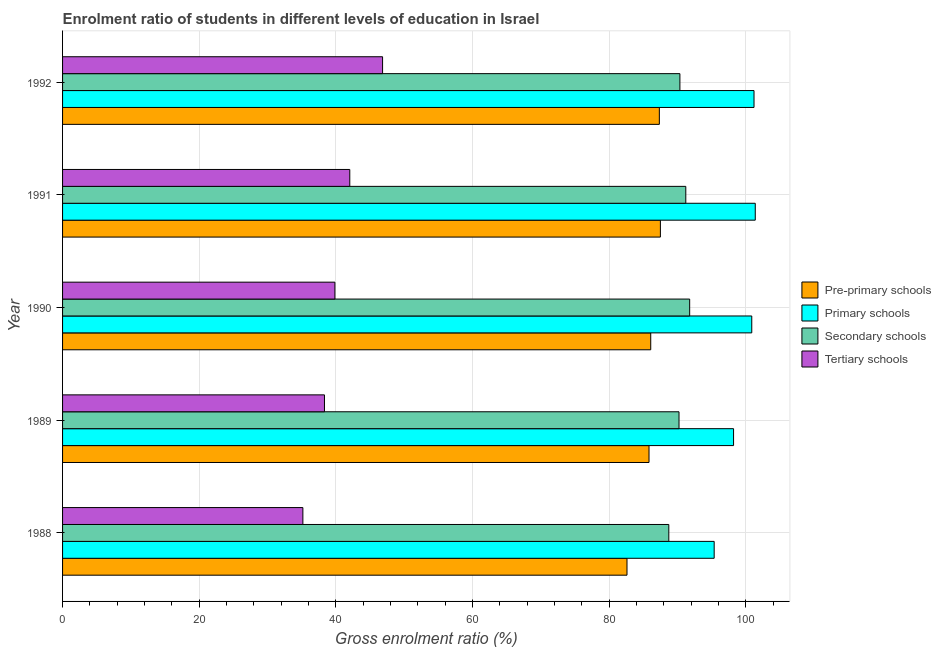How many different coloured bars are there?
Give a very brief answer. 4. How many groups of bars are there?
Your answer should be very brief. 5. Are the number of bars per tick equal to the number of legend labels?
Your answer should be compact. Yes. How many bars are there on the 4th tick from the top?
Offer a very short reply. 4. What is the label of the 2nd group of bars from the top?
Your answer should be very brief. 1991. What is the gross enrolment ratio in secondary schools in 1992?
Give a very brief answer. 90.36. Across all years, what is the maximum gross enrolment ratio in tertiary schools?
Ensure brevity in your answer.  46.84. Across all years, what is the minimum gross enrolment ratio in tertiary schools?
Offer a very short reply. 35.17. What is the total gross enrolment ratio in tertiary schools in the graph?
Provide a short and direct response. 202.24. What is the difference between the gross enrolment ratio in primary schools in 1988 and that in 1992?
Offer a terse response. -5.83. What is the difference between the gross enrolment ratio in primary schools in 1988 and the gross enrolment ratio in pre-primary schools in 1990?
Keep it short and to the point. 9.29. What is the average gross enrolment ratio in secondary schools per year?
Your answer should be very brief. 90.46. In the year 1990, what is the difference between the gross enrolment ratio in secondary schools and gross enrolment ratio in pre-primary schools?
Provide a succinct answer. 5.7. In how many years, is the gross enrolment ratio in secondary schools greater than 16 %?
Ensure brevity in your answer.  5. What is the ratio of the gross enrolment ratio in secondary schools in 1988 to that in 1991?
Keep it short and to the point. 0.97. What is the difference between the highest and the second highest gross enrolment ratio in tertiary schools?
Your answer should be very brief. 4.8. What is the difference between the highest and the lowest gross enrolment ratio in primary schools?
Offer a terse response. 6.01. In how many years, is the gross enrolment ratio in primary schools greater than the average gross enrolment ratio in primary schools taken over all years?
Give a very brief answer. 3. Is the sum of the gross enrolment ratio in secondary schools in 1988 and 1992 greater than the maximum gross enrolment ratio in primary schools across all years?
Ensure brevity in your answer.  Yes. Is it the case that in every year, the sum of the gross enrolment ratio in primary schools and gross enrolment ratio in pre-primary schools is greater than the sum of gross enrolment ratio in secondary schools and gross enrolment ratio in tertiary schools?
Make the answer very short. Yes. What does the 3rd bar from the top in 1990 represents?
Provide a short and direct response. Primary schools. What does the 3rd bar from the bottom in 1989 represents?
Provide a succinct answer. Secondary schools. Is it the case that in every year, the sum of the gross enrolment ratio in pre-primary schools and gross enrolment ratio in primary schools is greater than the gross enrolment ratio in secondary schools?
Your answer should be very brief. Yes. How many bars are there?
Offer a very short reply. 20. Are all the bars in the graph horizontal?
Ensure brevity in your answer.  Yes. Are the values on the major ticks of X-axis written in scientific E-notation?
Keep it short and to the point. No. Does the graph contain any zero values?
Give a very brief answer. No. Where does the legend appear in the graph?
Give a very brief answer. Center right. What is the title of the graph?
Offer a terse response. Enrolment ratio of students in different levels of education in Israel. Does "Other expenses" appear as one of the legend labels in the graph?
Offer a terse response. No. What is the label or title of the X-axis?
Ensure brevity in your answer.  Gross enrolment ratio (%). What is the label or title of the Y-axis?
Your response must be concise. Year. What is the Gross enrolment ratio (%) of Pre-primary schools in 1988?
Make the answer very short. 82.61. What is the Gross enrolment ratio (%) in Primary schools in 1988?
Offer a terse response. 95.37. What is the Gross enrolment ratio (%) in Secondary schools in 1988?
Make the answer very short. 88.73. What is the Gross enrolment ratio (%) in Tertiary schools in 1988?
Keep it short and to the point. 35.17. What is the Gross enrolment ratio (%) of Pre-primary schools in 1989?
Make the answer very short. 85.83. What is the Gross enrolment ratio (%) in Primary schools in 1989?
Offer a very short reply. 98.21. What is the Gross enrolment ratio (%) of Secondary schools in 1989?
Provide a succinct answer. 90.22. What is the Gross enrolment ratio (%) in Tertiary schools in 1989?
Offer a terse response. 38.33. What is the Gross enrolment ratio (%) of Pre-primary schools in 1990?
Your response must be concise. 86.08. What is the Gross enrolment ratio (%) of Primary schools in 1990?
Your answer should be very brief. 100.87. What is the Gross enrolment ratio (%) of Secondary schools in 1990?
Your answer should be very brief. 91.79. What is the Gross enrolment ratio (%) in Tertiary schools in 1990?
Give a very brief answer. 39.86. What is the Gross enrolment ratio (%) of Pre-primary schools in 1991?
Provide a succinct answer. 87.5. What is the Gross enrolment ratio (%) of Primary schools in 1991?
Offer a terse response. 101.38. What is the Gross enrolment ratio (%) in Secondary schools in 1991?
Offer a very short reply. 91.22. What is the Gross enrolment ratio (%) in Tertiary schools in 1991?
Make the answer very short. 42.04. What is the Gross enrolment ratio (%) in Pre-primary schools in 1992?
Your answer should be very brief. 87.35. What is the Gross enrolment ratio (%) of Primary schools in 1992?
Ensure brevity in your answer.  101.2. What is the Gross enrolment ratio (%) of Secondary schools in 1992?
Provide a short and direct response. 90.36. What is the Gross enrolment ratio (%) in Tertiary schools in 1992?
Ensure brevity in your answer.  46.84. Across all years, what is the maximum Gross enrolment ratio (%) in Pre-primary schools?
Provide a succinct answer. 87.5. Across all years, what is the maximum Gross enrolment ratio (%) of Primary schools?
Keep it short and to the point. 101.38. Across all years, what is the maximum Gross enrolment ratio (%) of Secondary schools?
Your response must be concise. 91.79. Across all years, what is the maximum Gross enrolment ratio (%) in Tertiary schools?
Offer a terse response. 46.84. Across all years, what is the minimum Gross enrolment ratio (%) of Pre-primary schools?
Make the answer very short. 82.61. Across all years, what is the minimum Gross enrolment ratio (%) of Primary schools?
Give a very brief answer. 95.37. Across all years, what is the minimum Gross enrolment ratio (%) in Secondary schools?
Your response must be concise. 88.73. Across all years, what is the minimum Gross enrolment ratio (%) of Tertiary schools?
Provide a succinct answer. 35.17. What is the total Gross enrolment ratio (%) of Pre-primary schools in the graph?
Provide a short and direct response. 429.37. What is the total Gross enrolment ratio (%) in Primary schools in the graph?
Ensure brevity in your answer.  497.04. What is the total Gross enrolment ratio (%) of Secondary schools in the graph?
Provide a succinct answer. 452.31. What is the total Gross enrolment ratio (%) in Tertiary schools in the graph?
Your answer should be very brief. 202.24. What is the difference between the Gross enrolment ratio (%) of Pre-primary schools in 1988 and that in 1989?
Make the answer very short. -3.22. What is the difference between the Gross enrolment ratio (%) in Primary schools in 1988 and that in 1989?
Keep it short and to the point. -2.84. What is the difference between the Gross enrolment ratio (%) of Secondary schools in 1988 and that in 1989?
Keep it short and to the point. -1.49. What is the difference between the Gross enrolment ratio (%) of Tertiary schools in 1988 and that in 1989?
Keep it short and to the point. -3.16. What is the difference between the Gross enrolment ratio (%) in Pre-primary schools in 1988 and that in 1990?
Ensure brevity in your answer.  -3.47. What is the difference between the Gross enrolment ratio (%) in Primary schools in 1988 and that in 1990?
Make the answer very short. -5.5. What is the difference between the Gross enrolment ratio (%) of Secondary schools in 1988 and that in 1990?
Your response must be concise. -3.05. What is the difference between the Gross enrolment ratio (%) in Tertiary schools in 1988 and that in 1990?
Provide a succinct answer. -4.69. What is the difference between the Gross enrolment ratio (%) in Pre-primary schools in 1988 and that in 1991?
Offer a very short reply. -4.89. What is the difference between the Gross enrolment ratio (%) in Primary schools in 1988 and that in 1991?
Offer a terse response. -6.01. What is the difference between the Gross enrolment ratio (%) in Secondary schools in 1988 and that in 1991?
Keep it short and to the point. -2.49. What is the difference between the Gross enrolment ratio (%) of Tertiary schools in 1988 and that in 1991?
Ensure brevity in your answer.  -6.87. What is the difference between the Gross enrolment ratio (%) of Pre-primary schools in 1988 and that in 1992?
Your response must be concise. -4.74. What is the difference between the Gross enrolment ratio (%) of Primary schools in 1988 and that in 1992?
Give a very brief answer. -5.83. What is the difference between the Gross enrolment ratio (%) in Secondary schools in 1988 and that in 1992?
Make the answer very short. -1.62. What is the difference between the Gross enrolment ratio (%) in Tertiary schools in 1988 and that in 1992?
Provide a succinct answer. -11.67. What is the difference between the Gross enrolment ratio (%) in Primary schools in 1989 and that in 1990?
Make the answer very short. -2.67. What is the difference between the Gross enrolment ratio (%) in Secondary schools in 1989 and that in 1990?
Your response must be concise. -1.56. What is the difference between the Gross enrolment ratio (%) in Tertiary schools in 1989 and that in 1990?
Give a very brief answer. -1.53. What is the difference between the Gross enrolment ratio (%) in Pre-primary schools in 1989 and that in 1991?
Make the answer very short. -1.66. What is the difference between the Gross enrolment ratio (%) in Primary schools in 1989 and that in 1991?
Give a very brief answer. -3.18. What is the difference between the Gross enrolment ratio (%) in Secondary schools in 1989 and that in 1991?
Your response must be concise. -0.99. What is the difference between the Gross enrolment ratio (%) in Tertiary schools in 1989 and that in 1991?
Your answer should be compact. -3.71. What is the difference between the Gross enrolment ratio (%) of Pre-primary schools in 1989 and that in 1992?
Offer a very short reply. -1.51. What is the difference between the Gross enrolment ratio (%) in Primary schools in 1989 and that in 1992?
Your answer should be compact. -3. What is the difference between the Gross enrolment ratio (%) in Secondary schools in 1989 and that in 1992?
Make the answer very short. -0.13. What is the difference between the Gross enrolment ratio (%) in Tertiary schools in 1989 and that in 1992?
Keep it short and to the point. -8.5. What is the difference between the Gross enrolment ratio (%) of Pre-primary schools in 1990 and that in 1991?
Ensure brevity in your answer.  -1.41. What is the difference between the Gross enrolment ratio (%) of Primary schools in 1990 and that in 1991?
Ensure brevity in your answer.  -0.51. What is the difference between the Gross enrolment ratio (%) in Secondary schools in 1990 and that in 1991?
Keep it short and to the point. 0.57. What is the difference between the Gross enrolment ratio (%) of Tertiary schools in 1990 and that in 1991?
Your answer should be very brief. -2.18. What is the difference between the Gross enrolment ratio (%) of Pre-primary schools in 1990 and that in 1992?
Ensure brevity in your answer.  -1.26. What is the difference between the Gross enrolment ratio (%) of Primary schools in 1990 and that in 1992?
Provide a short and direct response. -0.33. What is the difference between the Gross enrolment ratio (%) of Secondary schools in 1990 and that in 1992?
Make the answer very short. 1.43. What is the difference between the Gross enrolment ratio (%) of Tertiary schools in 1990 and that in 1992?
Make the answer very short. -6.98. What is the difference between the Gross enrolment ratio (%) in Pre-primary schools in 1991 and that in 1992?
Make the answer very short. 0.15. What is the difference between the Gross enrolment ratio (%) in Primary schools in 1991 and that in 1992?
Give a very brief answer. 0.18. What is the difference between the Gross enrolment ratio (%) of Secondary schools in 1991 and that in 1992?
Make the answer very short. 0.86. What is the difference between the Gross enrolment ratio (%) in Tertiary schools in 1991 and that in 1992?
Give a very brief answer. -4.8. What is the difference between the Gross enrolment ratio (%) in Pre-primary schools in 1988 and the Gross enrolment ratio (%) in Primary schools in 1989?
Offer a terse response. -15.6. What is the difference between the Gross enrolment ratio (%) of Pre-primary schools in 1988 and the Gross enrolment ratio (%) of Secondary schools in 1989?
Provide a succinct answer. -7.61. What is the difference between the Gross enrolment ratio (%) in Pre-primary schools in 1988 and the Gross enrolment ratio (%) in Tertiary schools in 1989?
Offer a terse response. 44.28. What is the difference between the Gross enrolment ratio (%) of Primary schools in 1988 and the Gross enrolment ratio (%) of Secondary schools in 1989?
Give a very brief answer. 5.15. What is the difference between the Gross enrolment ratio (%) of Primary schools in 1988 and the Gross enrolment ratio (%) of Tertiary schools in 1989?
Give a very brief answer. 57.04. What is the difference between the Gross enrolment ratio (%) in Secondary schools in 1988 and the Gross enrolment ratio (%) in Tertiary schools in 1989?
Make the answer very short. 50.4. What is the difference between the Gross enrolment ratio (%) in Pre-primary schools in 1988 and the Gross enrolment ratio (%) in Primary schools in 1990?
Your response must be concise. -18.26. What is the difference between the Gross enrolment ratio (%) in Pre-primary schools in 1988 and the Gross enrolment ratio (%) in Secondary schools in 1990?
Make the answer very short. -9.17. What is the difference between the Gross enrolment ratio (%) of Pre-primary schools in 1988 and the Gross enrolment ratio (%) of Tertiary schools in 1990?
Provide a succinct answer. 42.75. What is the difference between the Gross enrolment ratio (%) of Primary schools in 1988 and the Gross enrolment ratio (%) of Secondary schools in 1990?
Your answer should be compact. 3.58. What is the difference between the Gross enrolment ratio (%) of Primary schools in 1988 and the Gross enrolment ratio (%) of Tertiary schools in 1990?
Provide a short and direct response. 55.51. What is the difference between the Gross enrolment ratio (%) of Secondary schools in 1988 and the Gross enrolment ratio (%) of Tertiary schools in 1990?
Provide a succinct answer. 48.87. What is the difference between the Gross enrolment ratio (%) of Pre-primary schools in 1988 and the Gross enrolment ratio (%) of Primary schools in 1991?
Ensure brevity in your answer.  -18.77. What is the difference between the Gross enrolment ratio (%) in Pre-primary schools in 1988 and the Gross enrolment ratio (%) in Secondary schools in 1991?
Keep it short and to the point. -8.61. What is the difference between the Gross enrolment ratio (%) of Pre-primary schools in 1988 and the Gross enrolment ratio (%) of Tertiary schools in 1991?
Provide a short and direct response. 40.57. What is the difference between the Gross enrolment ratio (%) in Primary schools in 1988 and the Gross enrolment ratio (%) in Secondary schools in 1991?
Provide a short and direct response. 4.15. What is the difference between the Gross enrolment ratio (%) of Primary schools in 1988 and the Gross enrolment ratio (%) of Tertiary schools in 1991?
Make the answer very short. 53.33. What is the difference between the Gross enrolment ratio (%) in Secondary schools in 1988 and the Gross enrolment ratio (%) in Tertiary schools in 1991?
Make the answer very short. 46.69. What is the difference between the Gross enrolment ratio (%) in Pre-primary schools in 1988 and the Gross enrolment ratio (%) in Primary schools in 1992?
Ensure brevity in your answer.  -18.59. What is the difference between the Gross enrolment ratio (%) in Pre-primary schools in 1988 and the Gross enrolment ratio (%) in Secondary schools in 1992?
Provide a succinct answer. -7.74. What is the difference between the Gross enrolment ratio (%) in Pre-primary schools in 1988 and the Gross enrolment ratio (%) in Tertiary schools in 1992?
Make the answer very short. 35.77. What is the difference between the Gross enrolment ratio (%) in Primary schools in 1988 and the Gross enrolment ratio (%) in Secondary schools in 1992?
Offer a terse response. 5.01. What is the difference between the Gross enrolment ratio (%) of Primary schools in 1988 and the Gross enrolment ratio (%) of Tertiary schools in 1992?
Keep it short and to the point. 48.53. What is the difference between the Gross enrolment ratio (%) in Secondary schools in 1988 and the Gross enrolment ratio (%) in Tertiary schools in 1992?
Provide a succinct answer. 41.89. What is the difference between the Gross enrolment ratio (%) of Pre-primary schools in 1989 and the Gross enrolment ratio (%) of Primary schools in 1990?
Provide a succinct answer. -15.04. What is the difference between the Gross enrolment ratio (%) of Pre-primary schools in 1989 and the Gross enrolment ratio (%) of Secondary schools in 1990?
Provide a succinct answer. -5.95. What is the difference between the Gross enrolment ratio (%) of Pre-primary schools in 1989 and the Gross enrolment ratio (%) of Tertiary schools in 1990?
Your answer should be compact. 45.98. What is the difference between the Gross enrolment ratio (%) of Primary schools in 1989 and the Gross enrolment ratio (%) of Secondary schools in 1990?
Make the answer very short. 6.42. What is the difference between the Gross enrolment ratio (%) of Primary schools in 1989 and the Gross enrolment ratio (%) of Tertiary schools in 1990?
Keep it short and to the point. 58.35. What is the difference between the Gross enrolment ratio (%) in Secondary schools in 1989 and the Gross enrolment ratio (%) in Tertiary schools in 1990?
Offer a very short reply. 50.37. What is the difference between the Gross enrolment ratio (%) of Pre-primary schools in 1989 and the Gross enrolment ratio (%) of Primary schools in 1991?
Ensure brevity in your answer.  -15.55. What is the difference between the Gross enrolment ratio (%) of Pre-primary schools in 1989 and the Gross enrolment ratio (%) of Secondary schools in 1991?
Offer a very short reply. -5.38. What is the difference between the Gross enrolment ratio (%) of Pre-primary schools in 1989 and the Gross enrolment ratio (%) of Tertiary schools in 1991?
Keep it short and to the point. 43.8. What is the difference between the Gross enrolment ratio (%) in Primary schools in 1989 and the Gross enrolment ratio (%) in Secondary schools in 1991?
Your answer should be very brief. 6.99. What is the difference between the Gross enrolment ratio (%) in Primary schools in 1989 and the Gross enrolment ratio (%) in Tertiary schools in 1991?
Offer a terse response. 56.17. What is the difference between the Gross enrolment ratio (%) of Secondary schools in 1989 and the Gross enrolment ratio (%) of Tertiary schools in 1991?
Make the answer very short. 48.19. What is the difference between the Gross enrolment ratio (%) in Pre-primary schools in 1989 and the Gross enrolment ratio (%) in Primary schools in 1992?
Your answer should be compact. -15.37. What is the difference between the Gross enrolment ratio (%) of Pre-primary schools in 1989 and the Gross enrolment ratio (%) of Secondary schools in 1992?
Offer a terse response. -4.52. What is the difference between the Gross enrolment ratio (%) in Pre-primary schools in 1989 and the Gross enrolment ratio (%) in Tertiary schools in 1992?
Keep it short and to the point. 39. What is the difference between the Gross enrolment ratio (%) of Primary schools in 1989 and the Gross enrolment ratio (%) of Secondary schools in 1992?
Provide a succinct answer. 7.85. What is the difference between the Gross enrolment ratio (%) in Primary schools in 1989 and the Gross enrolment ratio (%) in Tertiary schools in 1992?
Ensure brevity in your answer.  51.37. What is the difference between the Gross enrolment ratio (%) of Secondary schools in 1989 and the Gross enrolment ratio (%) of Tertiary schools in 1992?
Provide a succinct answer. 43.39. What is the difference between the Gross enrolment ratio (%) of Pre-primary schools in 1990 and the Gross enrolment ratio (%) of Primary schools in 1991?
Your response must be concise. -15.3. What is the difference between the Gross enrolment ratio (%) in Pre-primary schools in 1990 and the Gross enrolment ratio (%) in Secondary schools in 1991?
Provide a succinct answer. -5.13. What is the difference between the Gross enrolment ratio (%) of Pre-primary schools in 1990 and the Gross enrolment ratio (%) of Tertiary schools in 1991?
Your answer should be compact. 44.05. What is the difference between the Gross enrolment ratio (%) of Primary schools in 1990 and the Gross enrolment ratio (%) of Secondary schools in 1991?
Offer a very short reply. 9.65. What is the difference between the Gross enrolment ratio (%) in Primary schools in 1990 and the Gross enrolment ratio (%) in Tertiary schools in 1991?
Keep it short and to the point. 58.83. What is the difference between the Gross enrolment ratio (%) of Secondary schools in 1990 and the Gross enrolment ratio (%) of Tertiary schools in 1991?
Your answer should be very brief. 49.75. What is the difference between the Gross enrolment ratio (%) in Pre-primary schools in 1990 and the Gross enrolment ratio (%) in Primary schools in 1992?
Your response must be concise. -15.12. What is the difference between the Gross enrolment ratio (%) of Pre-primary schools in 1990 and the Gross enrolment ratio (%) of Secondary schools in 1992?
Your answer should be very brief. -4.27. What is the difference between the Gross enrolment ratio (%) in Pre-primary schools in 1990 and the Gross enrolment ratio (%) in Tertiary schools in 1992?
Your response must be concise. 39.25. What is the difference between the Gross enrolment ratio (%) in Primary schools in 1990 and the Gross enrolment ratio (%) in Secondary schools in 1992?
Provide a short and direct response. 10.52. What is the difference between the Gross enrolment ratio (%) of Primary schools in 1990 and the Gross enrolment ratio (%) of Tertiary schools in 1992?
Your response must be concise. 54.03. What is the difference between the Gross enrolment ratio (%) of Secondary schools in 1990 and the Gross enrolment ratio (%) of Tertiary schools in 1992?
Your answer should be compact. 44.95. What is the difference between the Gross enrolment ratio (%) in Pre-primary schools in 1991 and the Gross enrolment ratio (%) in Primary schools in 1992?
Your answer should be very brief. -13.7. What is the difference between the Gross enrolment ratio (%) in Pre-primary schools in 1991 and the Gross enrolment ratio (%) in Secondary schools in 1992?
Keep it short and to the point. -2.86. What is the difference between the Gross enrolment ratio (%) of Pre-primary schools in 1991 and the Gross enrolment ratio (%) of Tertiary schools in 1992?
Ensure brevity in your answer.  40.66. What is the difference between the Gross enrolment ratio (%) of Primary schools in 1991 and the Gross enrolment ratio (%) of Secondary schools in 1992?
Provide a short and direct response. 11.03. What is the difference between the Gross enrolment ratio (%) in Primary schools in 1991 and the Gross enrolment ratio (%) in Tertiary schools in 1992?
Your response must be concise. 54.55. What is the difference between the Gross enrolment ratio (%) in Secondary schools in 1991 and the Gross enrolment ratio (%) in Tertiary schools in 1992?
Ensure brevity in your answer.  44.38. What is the average Gross enrolment ratio (%) of Pre-primary schools per year?
Your response must be concise. 85.87. What is the average Gross enrolment ratio (%) in Primary schools per year?
Your response must be concise. 99.41. What is the average Gross enrolment ratio (%) of Secondary schools per year?
Offer a very short reply. 90.46. What is the average Gross enrolment ratio (%) in Tertiary schools per year?
Your answer should be compact. 40.45. In the year 1988, what is the difference between the Gross enrolment ratio (%) in Pre-primary schools and Gross enrolment ratio (%) in Primary schools?
Your answer should be compact. -12.76. In the year 1988, what is the difference between the Gross enrolment ratio (%) of Pre-primary schools and Gross enrolment ratio (%) of Secondary schools?
Give a very brief answer. -6.12. In the year 1988, what is the difference between the Gross enrolment ratio (%) in Pre-primary schools and Gross enrolment ratio (%) in Tertiary schools?
Your answer should be very brief. 47.44. In the year 1988, what is the difference between the Gross enrolment ratio (%) of Primary schools and Gross enrolment ratio (%) of Secondary schools?
Ensure brevity in your answer.  6.64. In the year 1988, what is the difference between the Gross enrolment ratio (%) in Primary schools and Gross enrolment ratio (%) in Tertiary schools?
Make the answer very short. 60.2. In the year 1988, what is the difference between the Gross enrolment ratio (%) in Secondary schools and Gross enrolment ratio (%) in Tertiary schools?
Make the answer very short. 53.56. In the year 1989, what is the difference between the Gross enrolment ratio (%) of Pre-primary schools and Gross enrolment ratio (%) of Primary schools?
Keep it short and to the point. -12.37. In the year 1989, what is the difference between the Gross enrolment ratio (%) in Pre-primary schools and Gross enrolment ratio (%) in Secondary schools?
Your answer should be very brief. -4.39. In the year 1989, what is the difference between the Gross enrolment ratio (%) of Pre-primary schools and Gross enrolment ratio (%) of Tertiary schools?
Offer a very short reply. 47.5. In the year 1989, what is the difference between the Gross enrolment ratio (%) of Primary schools and Gross enrolment ratio (%) of Secondary schools?
Provide a succinct answer. 7.98. In the year 1989, what is the difference between the Gross enrolment ratio (%) of Primary schools and Gross enrolment ratio (%) of Tertiary schools?
Offer a very short reply. 59.87. In the year 1989, what is the difference between the Gross enrolment ratio (%) in Secondary schools and Gross enrolment ratio (%) in Tertiary schools?
Keep it short and to the point. 51.89. In the year 1990, what is the difference between the Gross enrolment ratio (%) of Pre-primary schools and Gross enrolment ratio (%) of Primary schools?
Your answer should be very brief. -14.79. In the year 1990, what is the difference between the Gross enrolment ratio (%) of Pre-primary schools and Gross enrolment ratio (%) of Secondary schools?
Keep it short and to the point. -5.7. In the year 1990, what is the difference between the Gross enrolment ratio (%) in Pre-primary schools and Gross enrolment ratio (%) in Tertiary schools?
Keep it short and to the point. 46.23. In the year 1990, what is the difference between the Gross enrolment ratio (%) in Primary schools and Gross enrolment ratio (%) in Secondary schools?
Give a very brief answer. 9.09. In the year 1990, what is the difference between the Gross enrolment ratio (%) in Primary schools and Gross enrolment ratio (%) in Tertiary schools?
Your answer should be compact. 61.01. In the year 1990, what is the difference between the Gross enrolment ratio (%) in Secondary schools and Gross enrolment ratio (%) in Tertiary schools?
Provide a succinct answer. 51.93. In the year 1991, what is the difference between the Gross enrolment ratio (%) of Pre-primary schools and Gross enrolment ratio (%) of Primary schools?
Provide a short and direct response. -13.89. In the year 1991, what is the difference between the Gross enrolment ratio (%) of Pre-primary schools and Gross enrolment ratio (%) of Secondary schools?
Make the answer very short. -3.72. In the year 1991, what is the difference between the Gross enrolment ratio (%) of Pre-primary schools and Gross enrolment ratio (%) of Tertiary schools?
Provide a short and direct response. 45.46. In the year 1991, what is the difference between the Gross enrolment ratio (%) of Primary schools and Gross enrolment ratio (%) of Secondary schools?
Your answer should be very brief. 10.17. In the year 1991, what is the difference between the Gross enrolment ratio (%) of Primary schools and Gross enrolment ratio (%) of Tertiary schools?
Your answer should be very brief. 59.35. In the year 1991, what is the difference between the Gross enrolment ratio (%) in Secondary schools and Gross enrolment ratio (%) in Tertiary schools?
Ensure brevity in your answer.  49.18. In the year 1992, what is the difference between the Gross enrolment ratio (%) in Pre-primary schools and Gross enrolment ratio (%) in Primary schools?
Keep it short and to the point. -13.86. In the year 1992, what is the difference between the Gross enrolment ratio (%) of Pre-primary schools and Gross enrolment ratio (%) of Secondary schools?
Make the answer very short. -3.01. In the year 1992, what is the difference between the Gross enrolment ratio (%) in Pre-primary schools and Gross enrolment ratio (%) in Tertiary schools?
Offer a very short reply. 40.51. In the year 1992, what is the difference between the Gross enrolment ratio (%) in Primary schools and Gross enrolment ratio (%) in Secondary schools?
Give a very brief answer. 10.85. In the year 1992, what is the difference between the Gross enrolment ratio (%) in Primary schools and Gross enrolment ratio (%) in Tertiary schools?
Your answer should be compact. 54.37. In the year 1992, what is the difference between the Gross enrolment ratio (%) of Secondary schools and Gross enrolment ratio (%) of Tertiary schools?
Give a very brief answer. 43.52. What is the ratio of the Gross enrolment ratio (%) of Pre-primary schools in 1988 to that in 1989?
Provide a succinct answer. 0.96. What is the ratio of the Gross enrolment ratio (%) in Primary schools in 1988 to that in 1989?
Your response must be concise. 0.97. What is the ratio of the Gross enrolment ratio (%) in Secondary schools in 1988 to that in 1989?
Keep it short and to the point. 0.98. What is the ratio of the Gross enrolment ratio (%) in Tertiary schools in 1988 to that in 1989?
Your answer should be compact. 0.92. What is the ratio of the Gross enrolment ratio (%) of Pre-primary schools in 1988 to that in 1990?
Keep it short and to the point. 0.96. What is the ratio of the Gross enrolment ratio (%) of Primary schools in 1988 to that in 1990?
Make the answer very short. 0.95. What is the ratio of the Gross enrolment ratio (%) of Secondary schools in 1988 to that in 1990?
Make the answer very short. 0.97. What is the ratio of the Gross enrolment ratio (%) of Tertiary schools in 1988 to that in 1990?
Ensure brevity in your answer.  0.88. What is the ratio of the Gross enrolment ratio (%) in Pre-primary schools in 1988 to that in 1991?
Provide a short and direct response. 0.94. What is the ratio of the Gross enrolment ratio (%) of Primary schools in 1988 to that in 1991?
Your response must be concise. 0.94. What is the ratio of the Gross enrolment ratio (%) of Secondary schools in 1988 to that in 1991?
Offer a very short reply. 0.97. What is the ratio of the Gross enrolment ratio (%) in Tertiary schools in 1988 to that in 1991?
Keep it short and to the point. 0.84. What is the ratio of the Gross enrolment ratio (%) in Pre-primary schools in 1988 to that in 1992?
Provide a short and direct response. 0.95. What is the ratio of the Gross enrolment ratio (%) of Primary schools in 1988 to that in 1992?
Make the answer very short. 0.94. What is the ratio of the Gross enrolment ratio (%) of Secondary schools in 1988 to that in 1992?
Provide a succinct answer. 0.98. What is the ratio of the Gross enrolment ratio (%) of Tertiary schools in 1988 to that in 1992?
Provide a succinct answer. 0.75. What is the ratio of the Gross enrolment ratio (%) in Pre-primary schools in 1989 to that in 1990?
Provide a succinct answer. 1. What is the ratio of the Gross enrolment ratio (%) of Primary schools in 1989 to that in 1990?
Your answer should be compact. 0.97. What is the ratio of the Gross enrolment ratio (%) in Secondary schools in 1989 to that in 1990?
Give a very brief answer. 0.98. What is the ratio of the Gross enrolment ratio (%) of Tertiary schools in 1989 to that in 1990?
Provide a short and direct response. 0.96. What is the ratio of the Gross enrolment ratio (%) in Primary schools in 1989 to that in 1991?
Provide a succinct answer. 0.97. What is the ratio of the Gross enrolment ratio (%) in Tertiary schools in 1989 to that in 1991?
Offer a very short reply. 0.91. What is the ratio of the Gross enrolment ratio (%) of Pre-primary schools in 1989 to that in 1992?
Keep it short and to the point. 0.98. What is the ratio of the Gross enrolment ratio (%) of Primary schools in 1989 to that in 1992?
Make the answer very short. 0.97. What is the ratio of the Gross enrolment ratio (%) of Tertiary schools in 1989 to that in 1992?
Make the answer very short. 0.82. What is the ratio of the Gross enrolment ratio (%) in Pre-primary schools in 1990 to that in 1991?
Offer a very short reply. 0.98. What is the ratio of the Gross enrolment ratio (%) in Secondary schools in 1990 to that in 1991?
Give a very brief answer. 1.01. What is the ratio of the Gross enrolment ratio (%) of Tertiary schools in 1990 to that in 1991?
Your answer should be compact. 0.95. What is the ratio of the Gross enrolment ratio (%) of Pre-primary schools in 1990 to that in 1992?
Provide a short and direct response. 0.99. What is the ratio of the Gross enrolment ratio (%) of Secondary schools in 1990 to that in 1992?
Offer a very short reply. 1.02. What is the ratio of the Gross enrolment ratio (%) in Tertiary schools in 1990 to that in 1992?
Ensure brevity in your answer.  0.85. What is the ratio of the Gross enrolment ratio (%) in Pre-primary schools in 1991 to that in 1992?
Ensure brevity in your answer.  1. What is the ratio of the Gross enrolment ratio (%) in Primary schools in 1991 to that in 1992?
Offer a very short reply. 1. What is the ratio of the Gross enrolment ratio (%) of Secondary schools in 1991 to that in 1992?
Provide a succinct answer. 1.01. What is the ratio of the Gross enrolment ratio (%) of Tertiary schools in 1991 to that in 1992?
Provide a succinct answer. 0.9. What is the difference between the highest and the second highest Gross enrolment ratio (%) of Pre-primary schools?
Make the answer very short. 0.15. What is the difference between the highest and the second highest Gross enrolment ratio (%) in Primary schools?
Provide a short and direct response. 0.18. What is the difference between the highest and the second highest Gross enrolment ratio (%) of Secondary schools?
Make the answer very short. 0.57. What is the difference between the highest and the second highest Gross enrolment ratio (%) of Tertiary schools?
Your response must be concise. 4.8. What is the difference between the highest and the lowest Gross enrolment ratio (%) of Pre-primary schools?
Provide a short and direct response. 4.89. What is the difference between the highest and the lowest Gross enrolment ratio (%) in Primary schools?
Offer a terse response. 6.01. What is the difference between the highest and the lowest Gross enrolment ratio (%) of Secondary schools?
Ensure brevity in your answer.  3.05. What is the difference between the highest and the lowest Gross enrolment ratio (%) in Tertiary schools?
Keep it short and to the point. 11.67. 